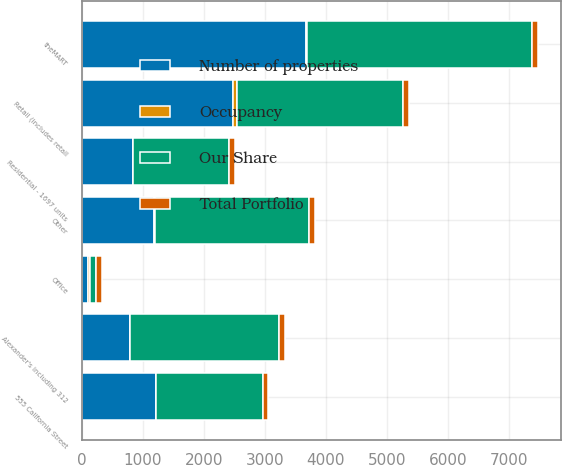<chart> <loc_0><loc_0><loc_500><loc_500><stacked_bar_chart><ecel><fcel>Office<fcel>Retail (includes retail<fcel>Residential - 1697 units<fcel>Alexander's including 312<fcel>theMART<fcel>555 California Street<fcel>Other<nl><fcel>Occupancy<fcel>36<fcel>71<fcel>11<fcel>7<fcel>3<fcel>3<fcel>11<nl><fcel>Our Share<fcel>98.95<fcel>2720<fcel>1568<fcel>2437<fcel>3689<fcel>1741<fcel>2525<nl><fcel>Number of properties<fcel>98.95<fcel>2471<fcel>835<fcel>790<fcel>3680<fcel>1219<fcel>1188<nl><fcel>Total Portfolio<fcel>97.1<fcel>96.9<fcel>96.7<fcel>99.3<fcel>98.6<fcel>94.2<fcel>93.6<nl></chart> 